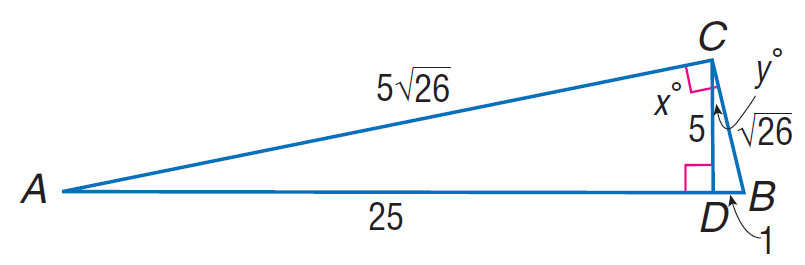Answer the mathemtical geometry problem and directly provide the correct option letter.
Question: Find \sin A.
Choices: A: \sqrt { 26 } / 26 B: \sqrt { 26 } / 22 C: \sqrt { 26 } / 5 D: \sqrt { 26 } / 3 A 